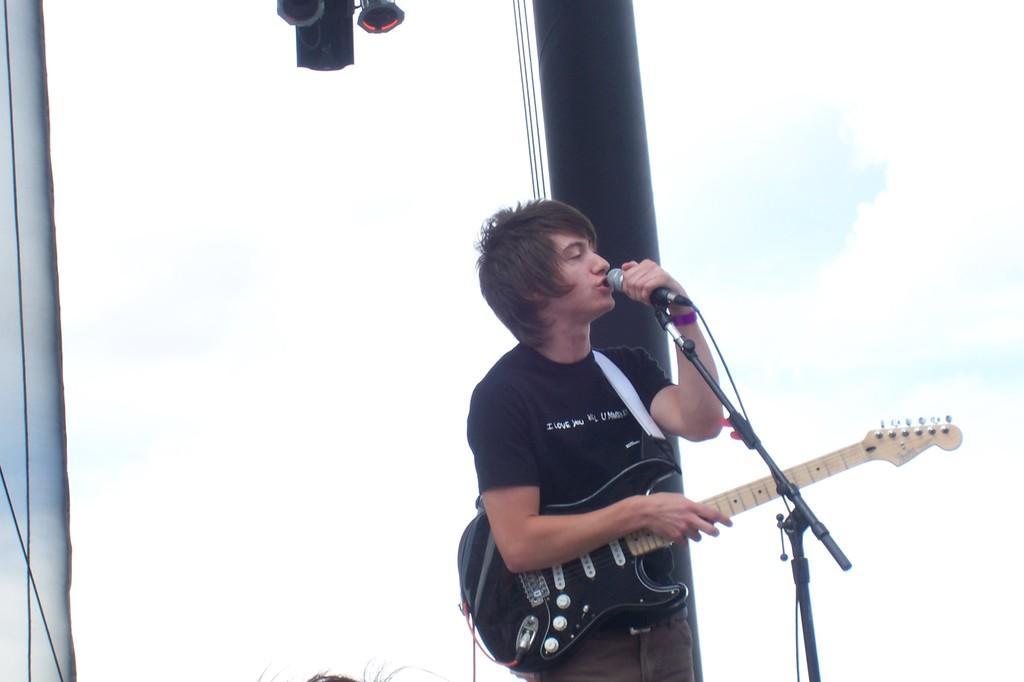Please provide a concise description of this image. In this image i can see a man holding guitar and singing in front of a micro phone at the back ground i can see a window. 